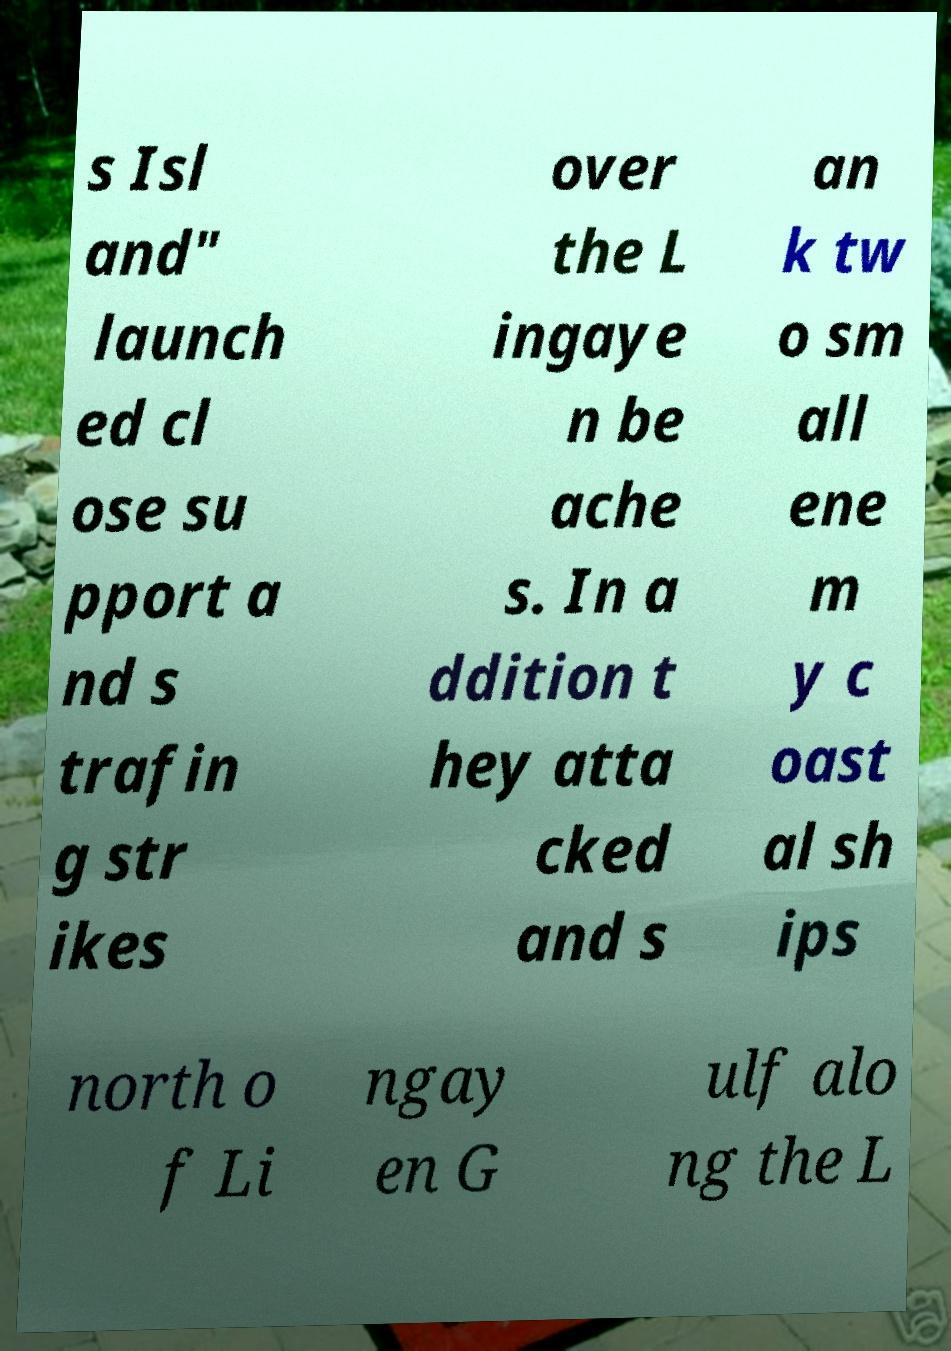I need the written content from this picture converted into text. Can you do that? s Isl and" launch ed cl ose su pport a nd s trafin g str ikes over the L ingaye n be ache s. In a ddition t hey atta cked and s an k tw o sm all ene m y c oast al sh ips north o f Li ngay en G ulf alo ng the L 